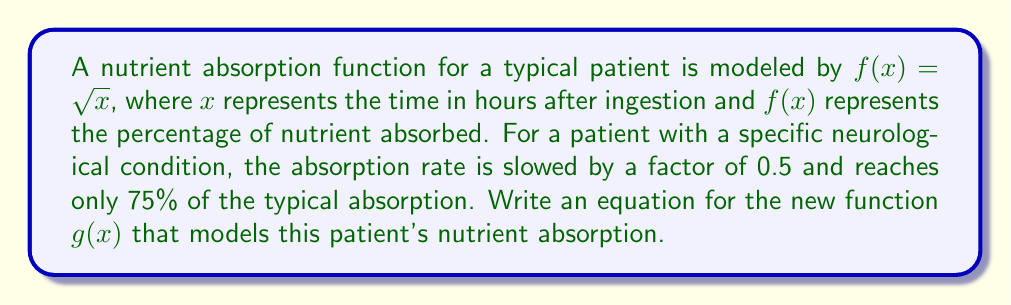Can you solve this math problem? To model the patient with the neurological condition, we need to apply two transformations to the original function $f(x) = \sqrt{x}$:

1. Slow the absorption rate by a factor of 0.5:
   This means we need to stretch the function horizontally by a factor of 2.
   We replace $x$ with $\frac{x}{2}$ in the original function.
   $f(\frac{x}{2}) = \sqrt{\frac{x}{2}}$

2. Reduce the maximum absorption to 75%:
   This means we need to vertically compress the function by a factor of 0.75.
   We multiply the entire function by 0.75.
   $0.75 \cdot f(\frac{x}{2}) = 0.75 \sqrt{\frac{x}{2}}$

Combining these transformations, we get the new function $g(x)$:

$$g(x) = 0.75 \sqrt{\frac{x}{2}}$$

This function represents the nutrient absorption for the patient with the neurological condition, where the absorption is slowed and reaches only 75% of the typical absorption.
Answer: $g(x) = 0.75 \sqrt{\frac{x}{2}}$ 